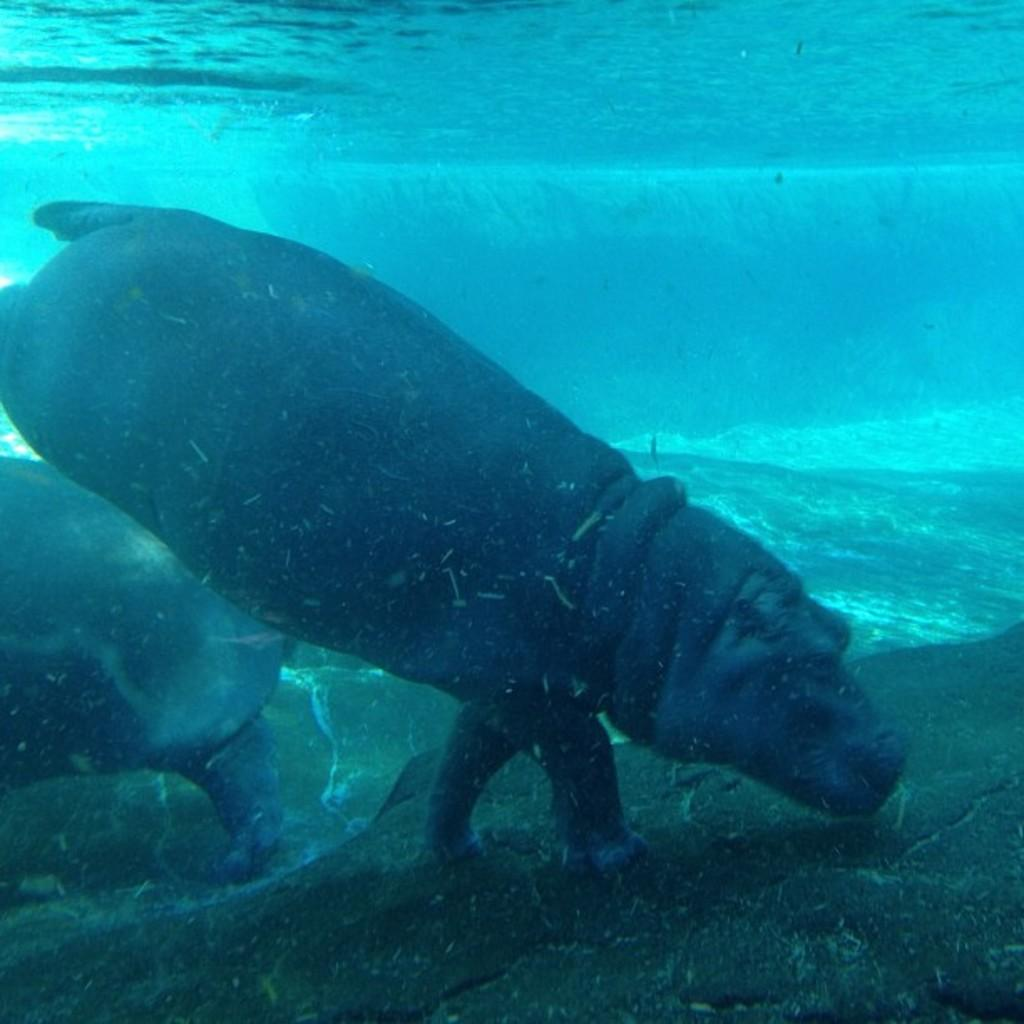What type of animals can be seen in the image? There are animals in the water. What is visible at the bottom of the image? There is a rock surface visible at the bottom of the image. How many eggs can be seen on the zebra in the image? There is no zebra or eggs present in the image. What type of respect is shown by the animals in the image? There is no indication of respect or any interaction between the animals in the image. 